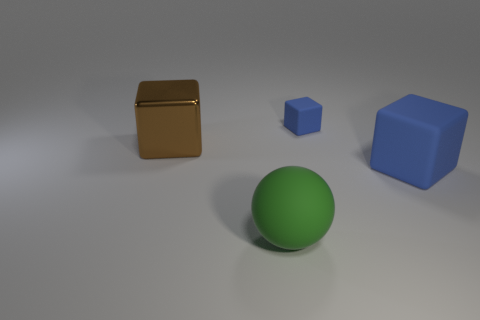Is the color of the big rubber cube the same as the tiny matte object?
Give a very brief answer. Yes. There is a blue rubber object on the left side of the block that is in front of the brown metal block; what size is it?
Give a very brief answer. Small. Is there a brown metallic ball of the same size as the brown block?
Offer a terse response. No. What is the color of the large object that is made of the same material as the big ball?
Give a very brief answer. Blue. Is the number of blue rubber objects less than the number of rubber objects?
Keep it short and to the point. Yes. There is a cube that is to the left of the big blue thing and to the right of the big matte ball; what is its material?
Offer a terse response. Rubber. There is a thing on the left side of the big rubber ball; are there any metal things behind it?
Your response must be concise. No. What number of tiny cylinders are the same color as the small matte block?
Offer a very short reply. 0. There is another cube that is the same color as the small block; what is it made of?
Provide a succinct answer. Rubber. Is the big brown block made of the same material as the small blue cube?
Give a very brief answer. No. 